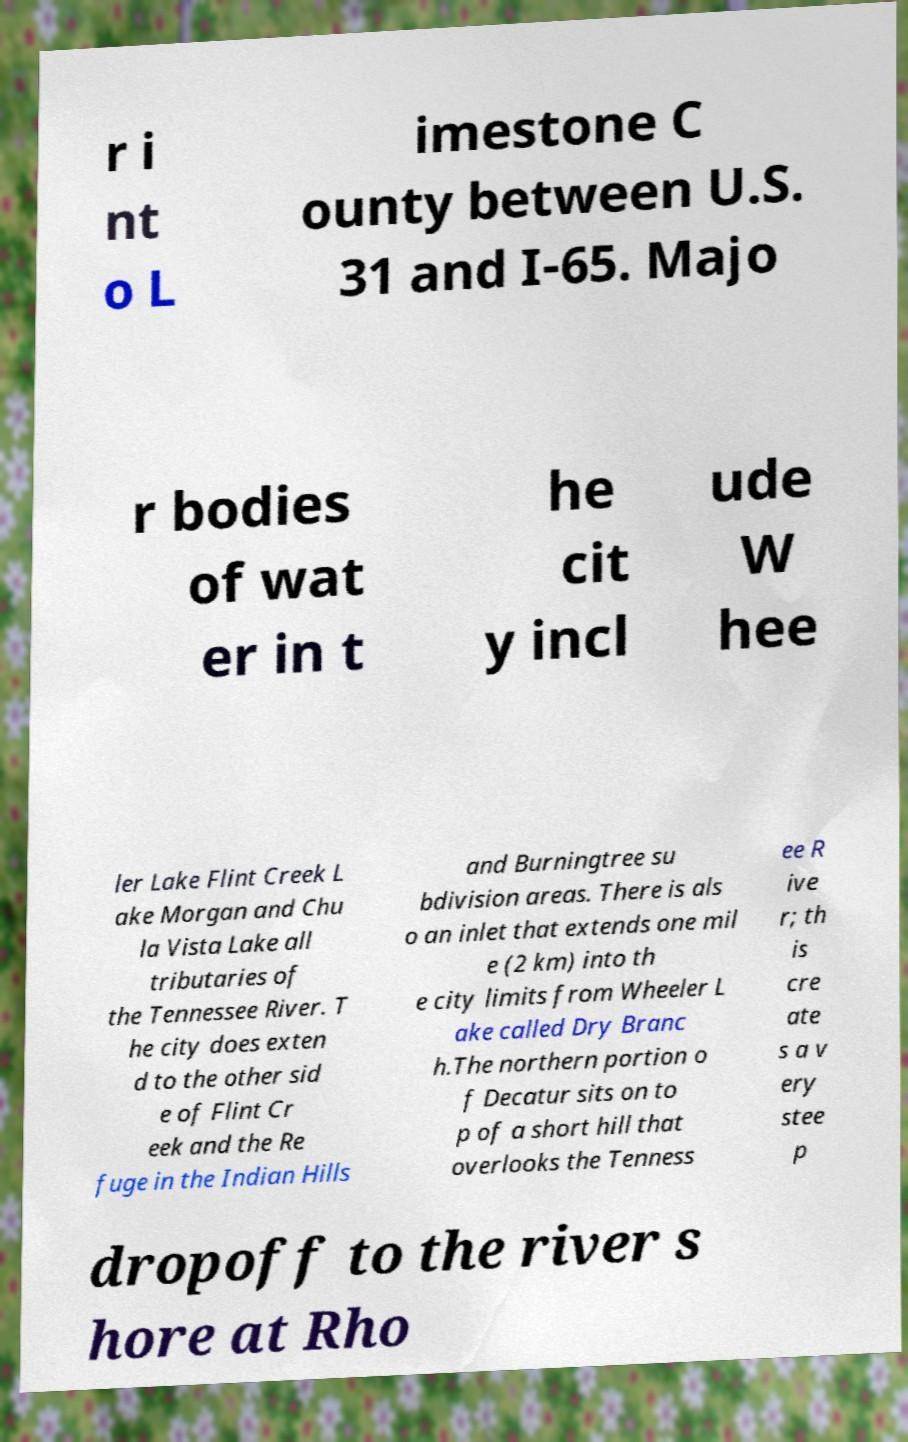What messages or text are displayed in this image? I need them in a readable, typed format. r i nt o L imestone C ounty between U.S. 31 and I-65. Majo r bodies of wat er in t he cit y incl ude W hee ler Lake Flint Creek L ake Morgan and Chu la Vista Lake all tributaries of the Tennessee River. T he city does exten d to the other sid e of Flint Cr eek and the Re fuge in the Indian Hills and Burningtree su bdivision areas. There is als o an inlet that extends one mil e (2 km) into th e city limits from Wheeler L ake called Dry Branc h.The northern portion o f Decatur sits on to p of a short hill that overlooks the Tenness ee R ive r; th is cre ate s a v ery stee p dropoff to the river s hore at Rho 